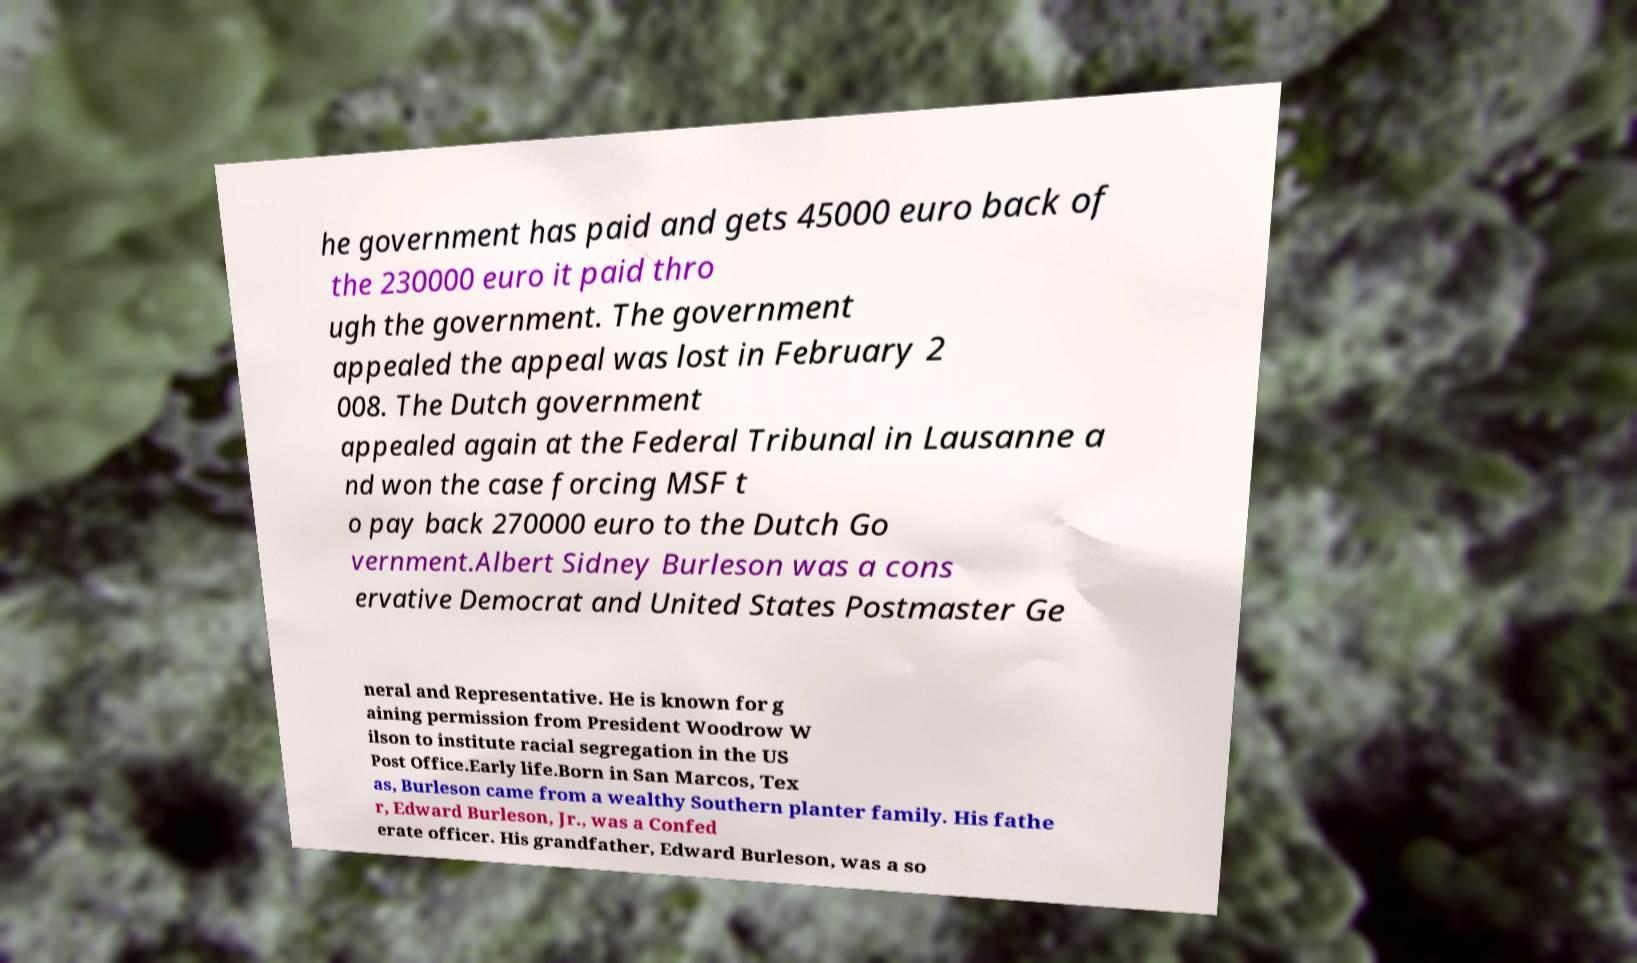Please identify and transcribe the text found in this image. he government has paid and gets 45000 euro back of the 230000 euro it paid thro ugh the government. The government appealed the appeal was lost in February 2 008. The Dutch government appealed again at the Federal Tribunal in Lausanne a nd won the case forcing MSF t o pay back 270000 euro to the Dutch Go vernment.Albert Sidney Burleson was a cons ervative Democrat and United States Postmaster Ge neral and Representative. He is known for g aining permission from President Woodrow W ilson to institute racial segregation in the US Post Office.Early life.Born in San Marcos, Tex as, Burleson came from a wealthy Southern planter family. His fathe r, Edward Burleson, Jr., was a Confed erate officer. His grandfather, Edward Burleson, was a so 